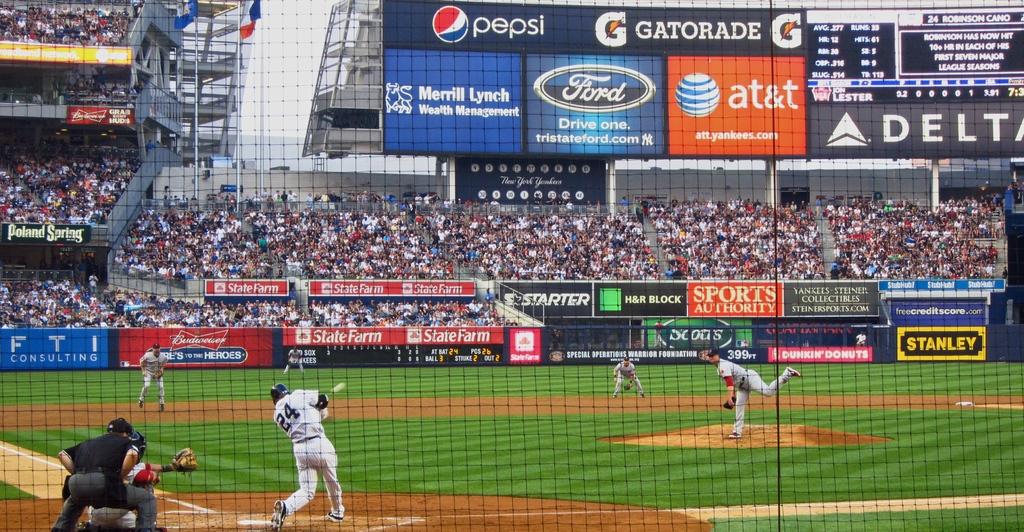What car company sponsors this event?
Provide a succinct answer. Ford. Does delta sponsor this event?
Offer a very short reply. Yes. 